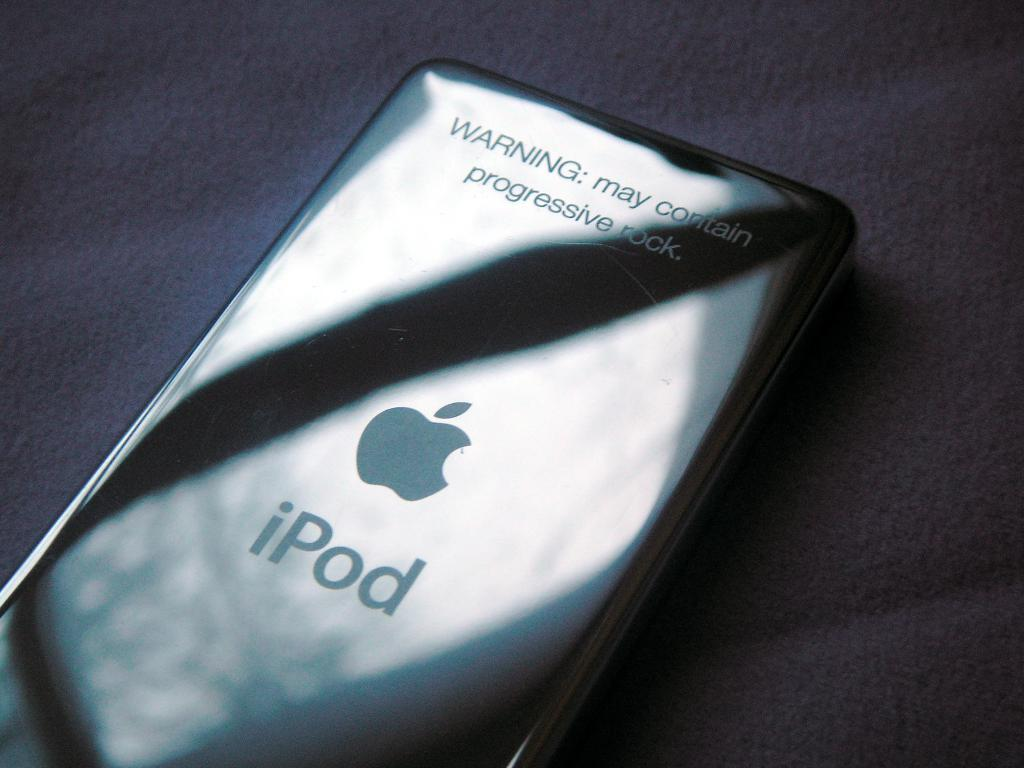<image>
Share a concise interpretation of the image provided. A silver iPod lays with the sun reflecting off its back. 